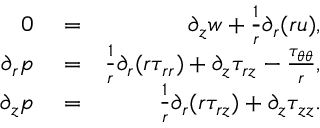<formula> <loc_0><loc_0><loc_500><loc_500>\begin{array} { r l r } { 0 } & = } & { \partial _ { z } { w } + \frac { 1 } { r } \partial _ { r } ( r { u } ) , } \\ { \partial _ { r } { p } } & = } & { \frac { 1 } { r } \partial _ { r } ( r \tau _ { r r } ) + \partial _ { z } \tau _ { r z } - \frac { \tau _ { \theta \theta } } { r } , } \\ { \partial _ { z } { p } } & = } & { \frac { 1 } { r } \partial _ { r } ( r \tau _ { r z } ) + \partial _ { z } \tau _ { z z } . } \end{array}</formula> 